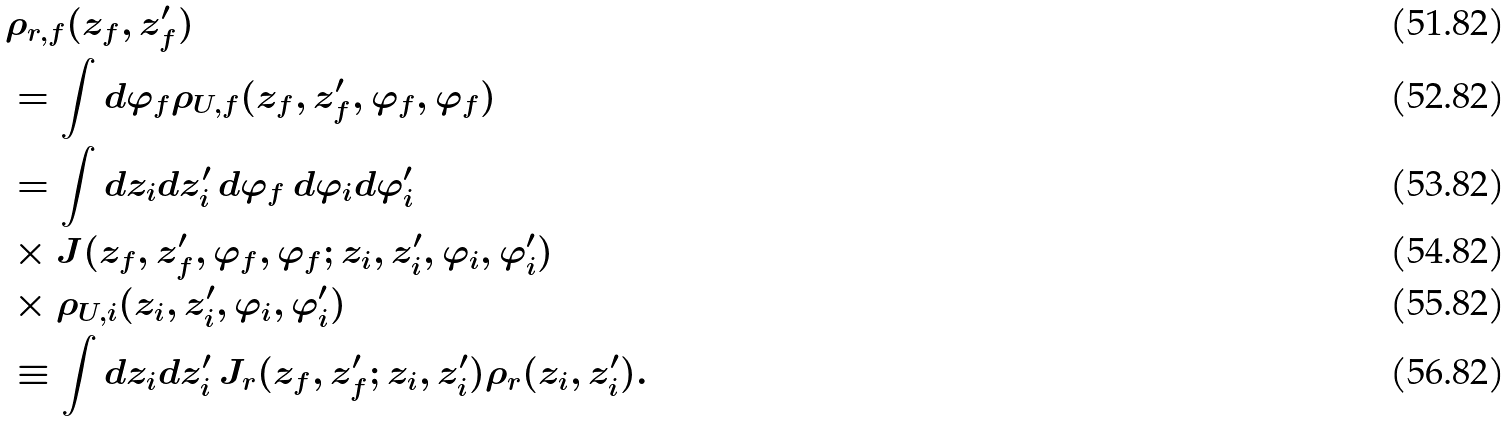Convert formula to latex. <formula><loc_0><loc_0><loc_500><loc_500>& \rho _ { r , f } ( z _ { f } , z _ { f } ^ { \prime } ) \\ & = \int d \varphi _ { f } \rho _ { U , f } ( z _ { f } , z _ { f } ^ { \prime } , \varphi _ { f } , \varphi _ { f } ) \\ & = \int d { z } _ { i } d { z } _ { i } ^ { \prime } \, d \varphi _ { f } \, d \varphi _ { i } d \varphi _ { i } ^ { \prime } \, \\ & \times J ( z _ { f } , z _ { f } ^ { \prime } , \varphi _ { f } , \varphi _ { f } ; z _ { i } , z _ { i } ^ { \prime } , \varphi _ { i } , \varphi _ { i } ^ { \prime } ) \\ & \times \rho _ { U , i } ( z _ { i } , z _ { i } ^ { \prime } , \varphi _ { i } , \varphi _ { i } ^ { \prime } ) \\ & \equiv \int d { z } _ { i } d { z } _ { i } ^ { \prime } \, J _ { r } ( z _ { f } , z _ { f } ^ { \prime } ; z _ { i } , z _ { i } ^ { \prime } ) \rho _ { r } ( z _ { i } , z _ { i } ^ { \prime } ) .</formula> 